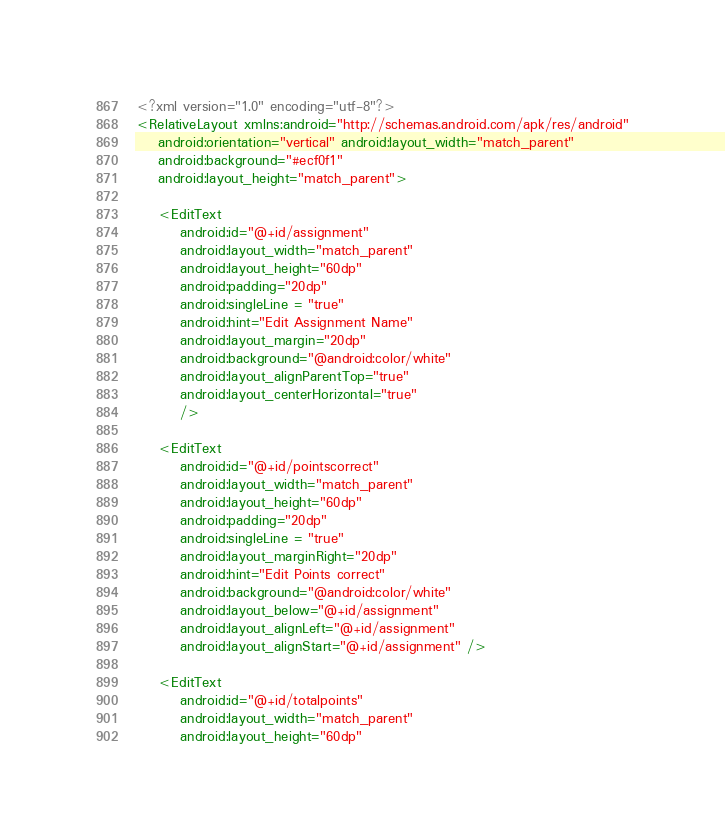Convert code to text. <code><loc_0><loc_0><loc_500><loc_500><_XML_><?xml version="1.0" encoding="utf-8"?>
<RelativeLayout xmlns:android="http://schemas.android.com/apk/res/android"
    android:orientation="vertical" android:layout_width="match_parent"
    android:background="#ecf0f1"
    android:layout_height="match_parent">

    <EditText
        android:id="@+id/assignment"
        android:layout_width="match_parent"
        android:layout_height="60dp"
        android:padding="20dp"
        android:singleLine = "true"
        android:hint="Edit Assignment Name"
        android:layout_margin="20dp"
        android:background="@android:color/white"
        android:layout_alignParentTop="true"
        android:layout_centerHorizontal="true"
        />

    <EditText
        android:id="@+id/pointscorrect"
        android:layout_width="match_parent"
        android:layout_height="60dp"
        android:padding="20dp"
        android:singleLine = "true"
        android:layout_marginRight="20dp"
        android:hint="Edit Points correct"
        android:background="@android:color/white"
        android:layout_below="@+id/assignment"
        android:layout_alignLeft="@+id/assignment"
        android:layout_alignStart="@+id/assignment" />

    <EditText
        android:id="@+id/totalpoints"
        android:layout_width="match_parent"
        android:layout_height="60dp"</code> 